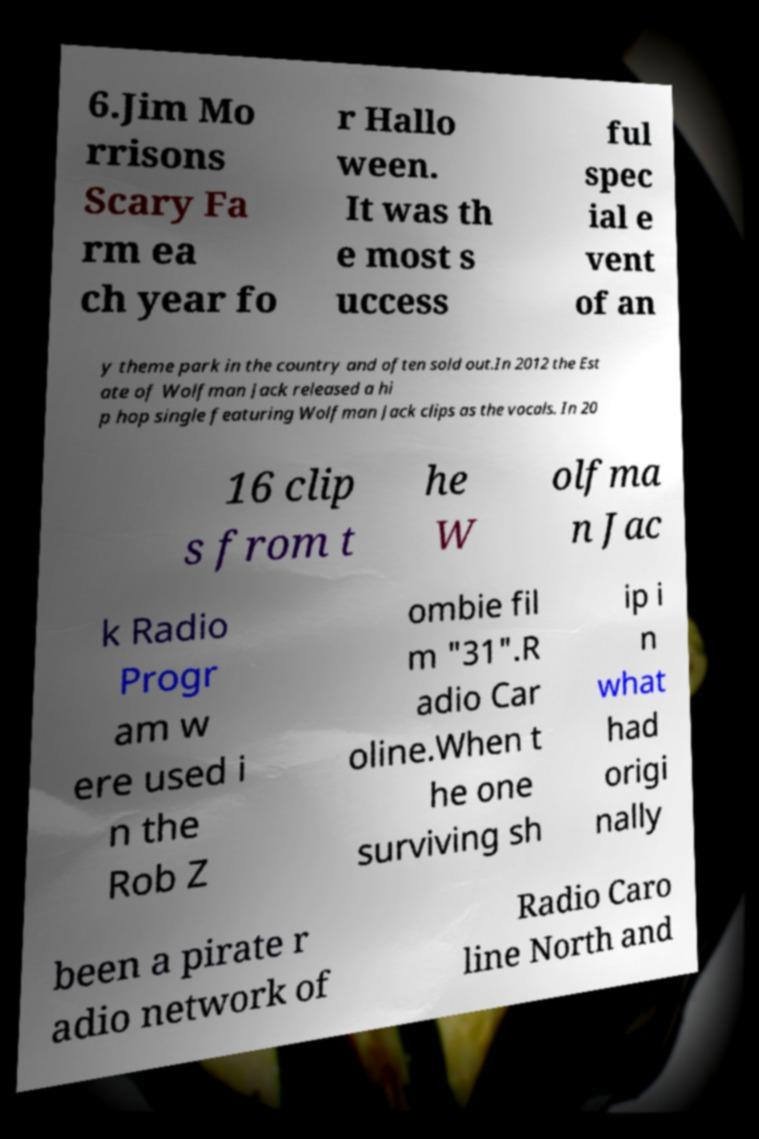Could you extract and type out the text from this image? 6.Jim Mo rrisons Scary Fa rm ea ch year fo r Hallo ween. It was th e most s uccess ful spec ial e vent of an y theme park in the country and often sold out.In 2012 the Est ate of Wolfman Jack released a hi p hop single featuring Wolfman Jack clips as the vocals. In 20 16 clip s from t he W olfma n Jac k Radio Progr am w ere used i n the Rob Z ombie fil m "31".R adio Car oline.When t he one surviving sh ip i n what had origi nally been a pirate r adio network of Radio Caro line North and 